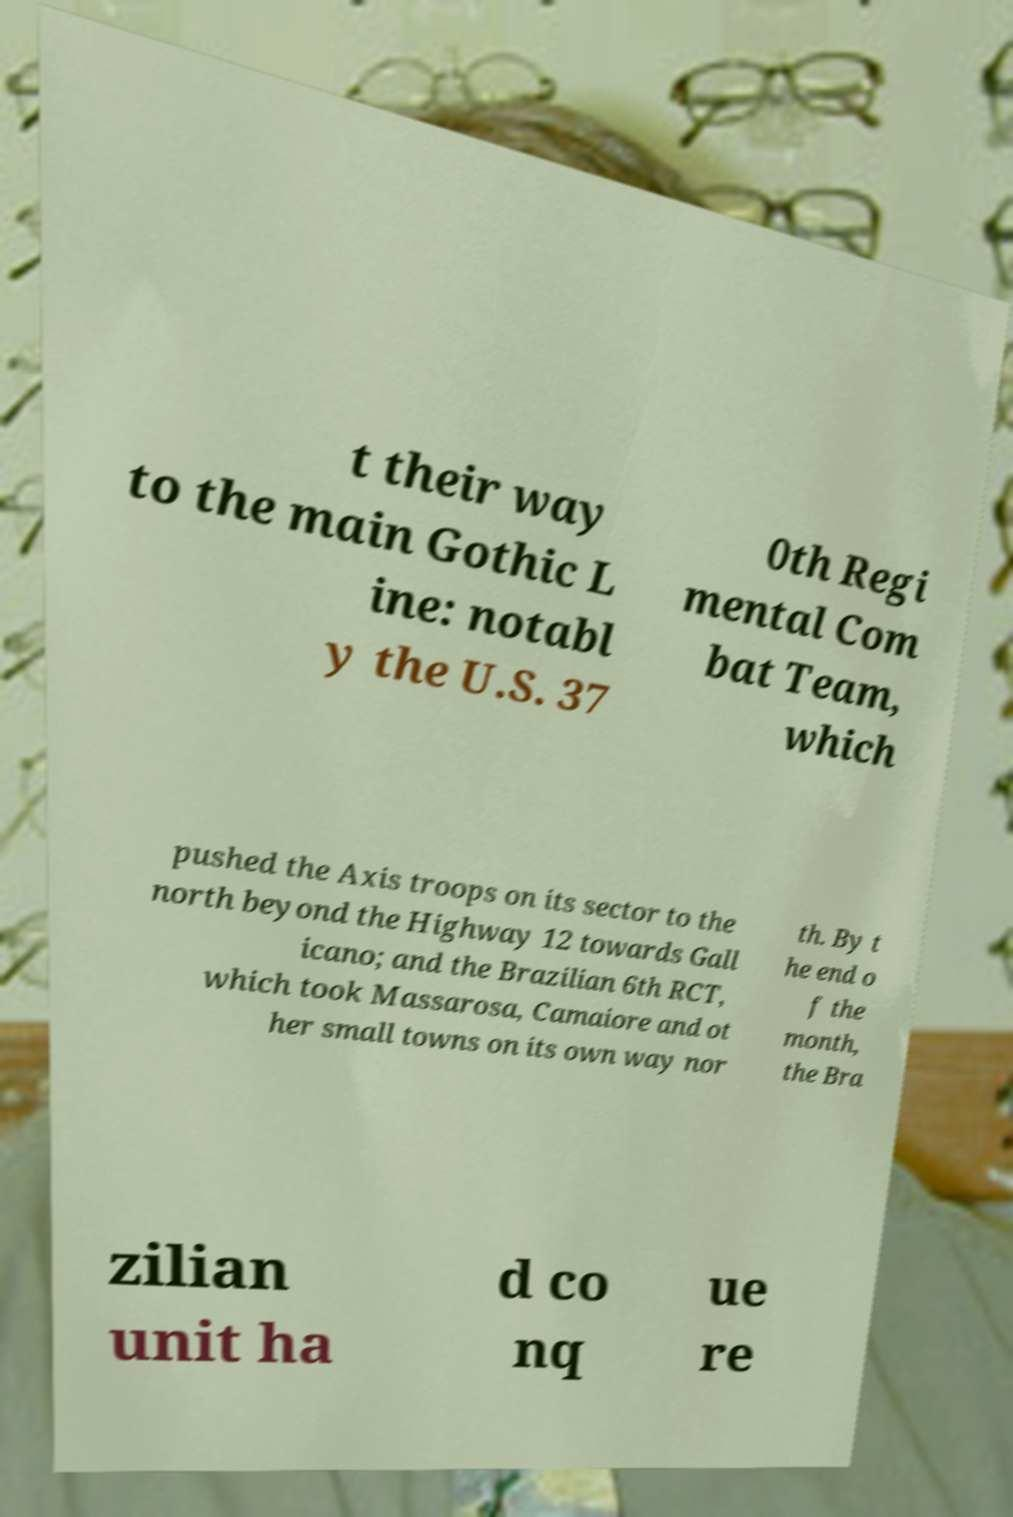There's text embedded in this image that I need extracted. Can you transcribe it verbatim? t their way to the main Gothic L ine: notabl y the U.S. 37 0th Regi mental Com bat Team, which pushed the Axis troops on its sector to the north beyond the Highway 12 towards Gall icano; and the Brazilian 6th RCT, which took Massarosa, Camaiore and ot her small towns on its own way nor th. By t he end o f the month, the Bra zilian unit ha d co nq ue re 